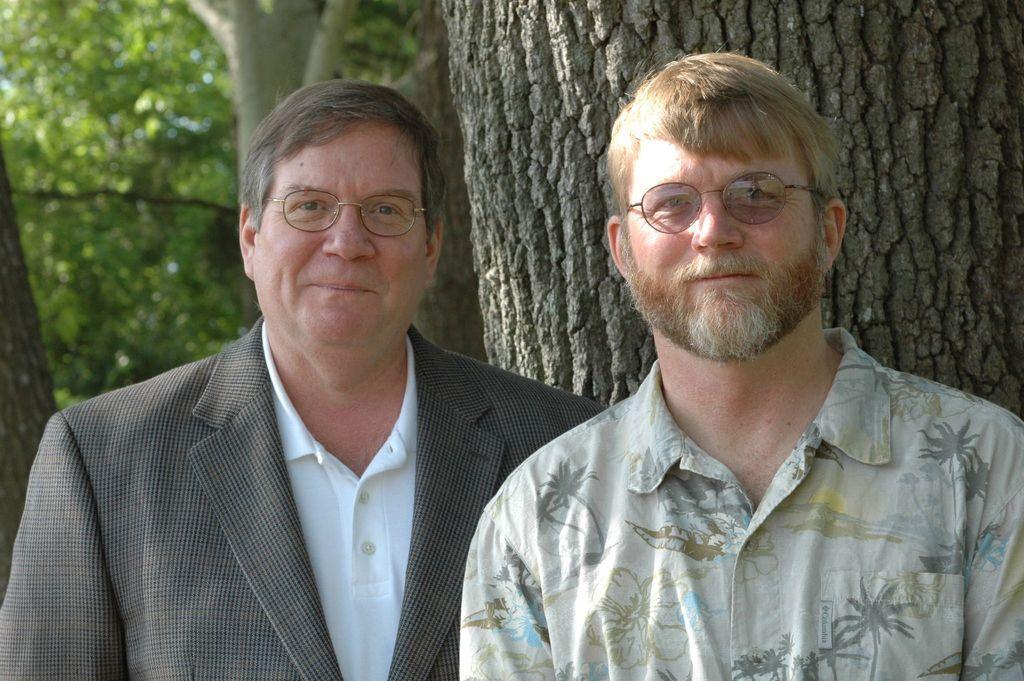In one or two sentences, can you explain what this image depicts? In this image we can see two men standing wearing the spectacles. On the backside we can see the bark of the trees and some trees. 